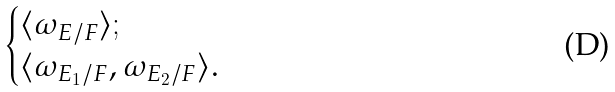Convert formula to latex. <formula><loc_0><loc_0><loc_500><loc_500>\begin{cases} \langle \omega _ { E / F } \rangle ; \\ \langle \omega _ { E _ { 1 } / F } , \omega _ { E _ { 2 } / F } \rangle . \end{cases}</formula> 